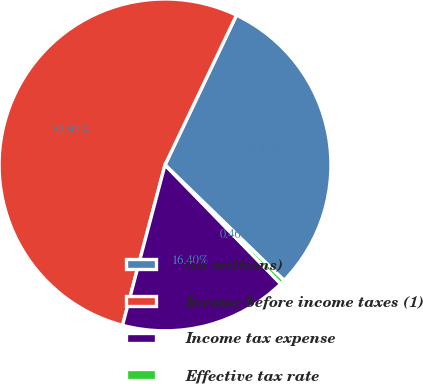Convert chart. <chart><loc_0><loc_0><loc_500><loc_500><pie_chart><fcel>(in millions)<fcel>Income before income taxes (1)<fcel>Income tax expense<fcel>Effective tax rate<nl><fcel>30.17%<fcel>52.96%<fcel>16.4%<fcel>0.46%<nl></chart> 